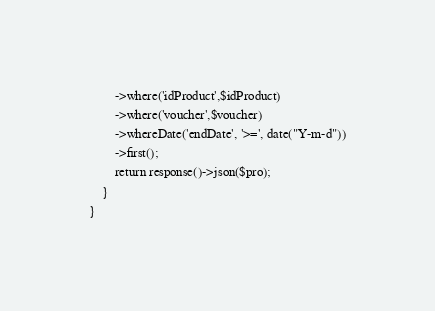<code> <loc_0><loc_0><loc_500><loc_500><_PHP_>        ->where('idProduct',$idProduct)
        ->where('voucher',$voucher)
        ->whereDate('endDate', '>=', date("Y-m-d"))
        ->first();
        return response()->json($pro);
    }
}
</code> 